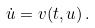<formula> <loc_0><loc_0><loc_500><loc_500>\dot { u } = v ( t , u ) \, .</formula> 